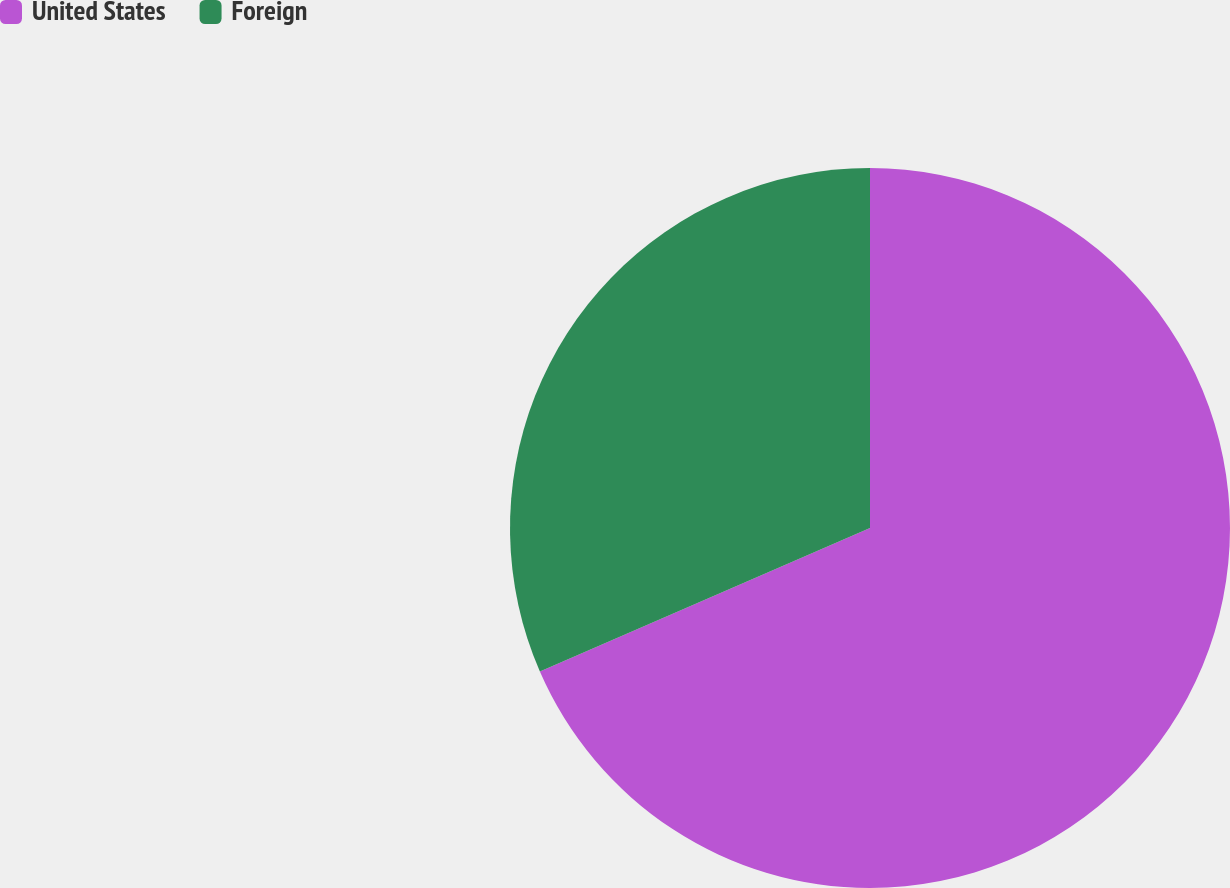<chart> <loc_0><loc_0><loc_500><loc_500><pie_chart><fcel>United States<fcel>Foreign<nl><fcel>68.47%<fcel>31.53%<nl></chart> 